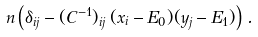<formula> <loc_0><loc_0><loc_500><loc_500>n \left ( \delta _ { i j } - ( C ^ { - 1 } ) _ { i j } \, ( x _ { i } - E _ { 0 } ) ( y _ { j } - E _ { 1 } ) \right ) \, .</formula> 